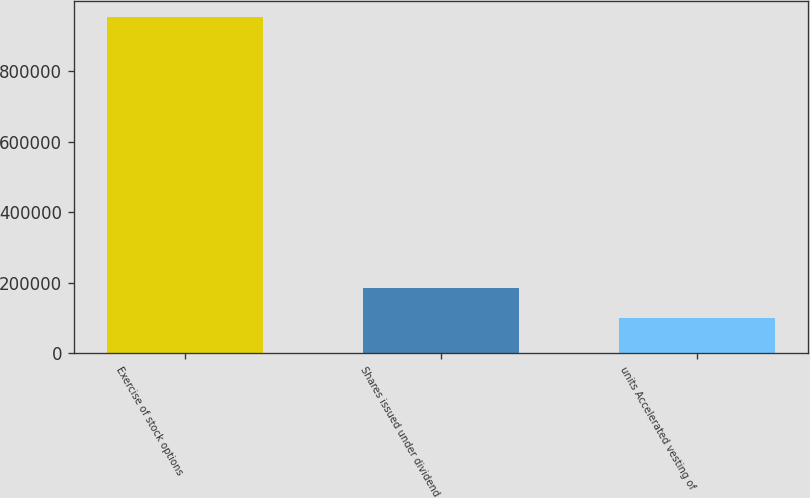Convert chart. <chart><loc_0><loc_0><loc_500><loc_500><bar_chart><fcel>Exercise of stock options<fcel>Shares issued under dividend<fcel>units Accelerated vesting of<nl><fcel>951971<fcel>185197<fcel>100000<nl></chart> 